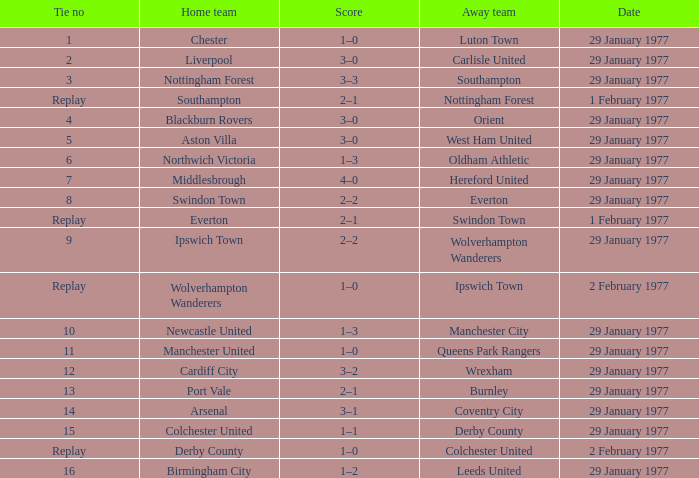What is the current score of the liverpool home match? 3–0. 